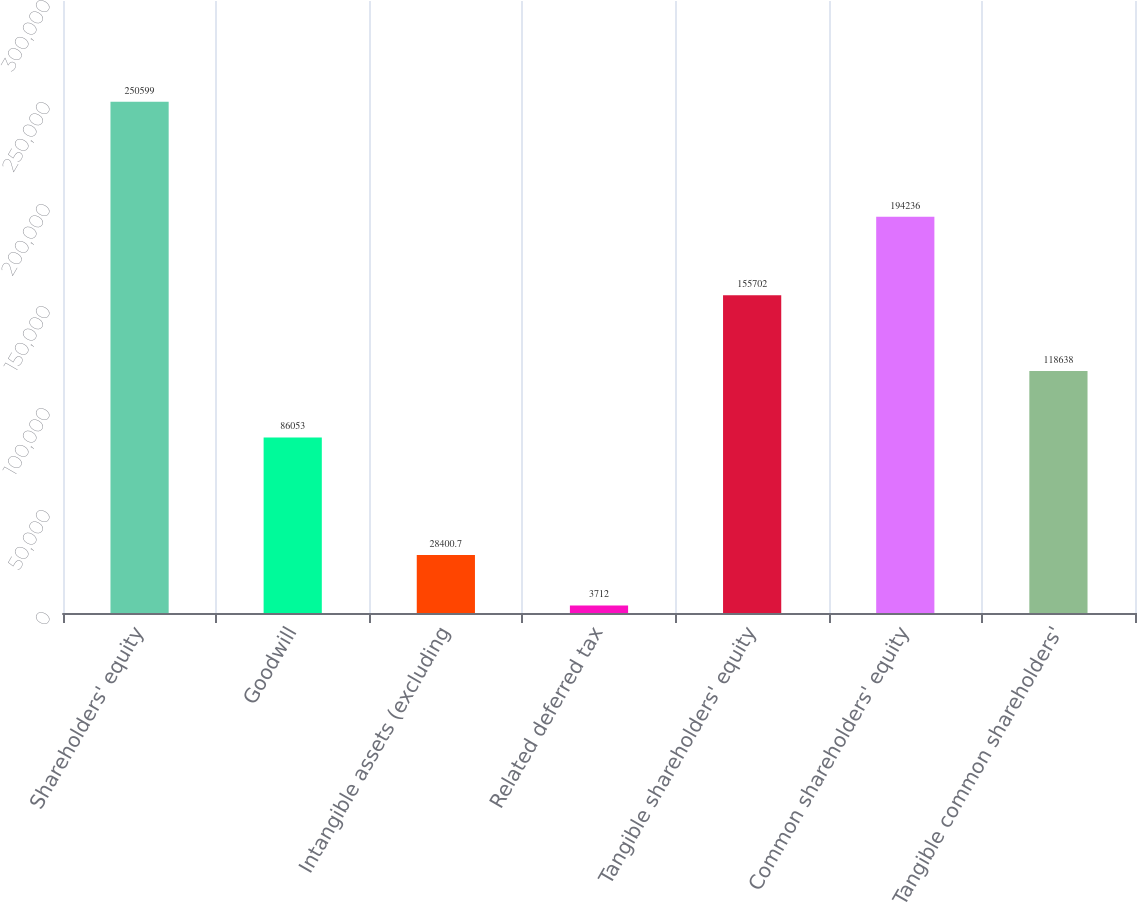<chart> <loc_0><loc_0><loc_500><loc_500><bar_chart><fcel>Shareholders' equity<fcel>Goodwill<fcel>Intangible assets (excluding<fcel>Related deferred tax<fcel>Tangible shareholders' equity<fcel>Common shareholders' equity<fcel>Tangible common shareholders'<nl><fcel>250599<fcel>86053<fcel>28400.7<fcel>3712<fcel>155702<fcel>194236<fcel>118638<nl></chart> 